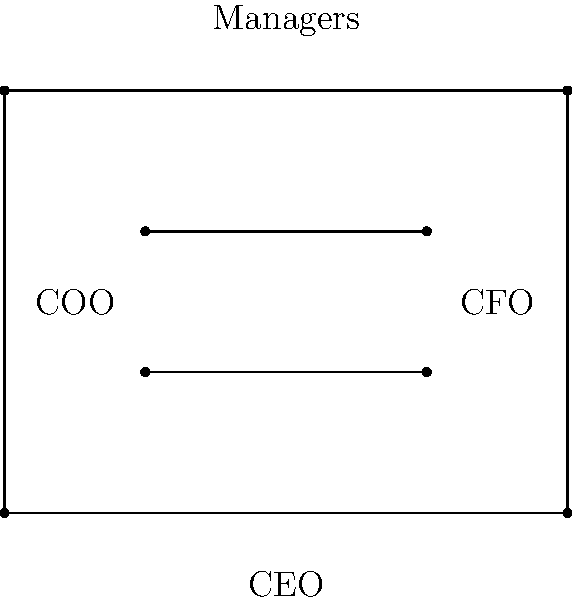In the organizational hierarchy diagram above, which represents a simplified structure of MaloneBailey, LLP, the line segments representing the COO and CFO positions appear to be congruent. If the length of the CEO's line segment is 4 units, what is the length of each of the congruent segments representing the COO and CFO positions? To solve this problem, we'll follow these steps:

1) First, we observe that the diagram is a rectangle, with the CEO's position forming the base.

2) The CEO's line segment spans the entire width of the rectangle, which is given as 4 units.

3) The COO and CFO positions are represented by line segments that appear to be parallel to the CEO's line segment and equal to each other.

4) These segments (COO and CFO) don't span the entire width of the rectangle. They appear to start and end at equal distances from the sides of the rectangle.

5) By visual estimation, we can see that the COO and CFO line segments cover about half the width of the rectangle.

6) Since the full width (CEO's line segment) is 4 units, half of this would be:

   $$\frac{4}{2} = 2$$

Therefore, each of the congruent segments representing the COO and CFO positions is approximately 2 units long.
Answer: 2 units 